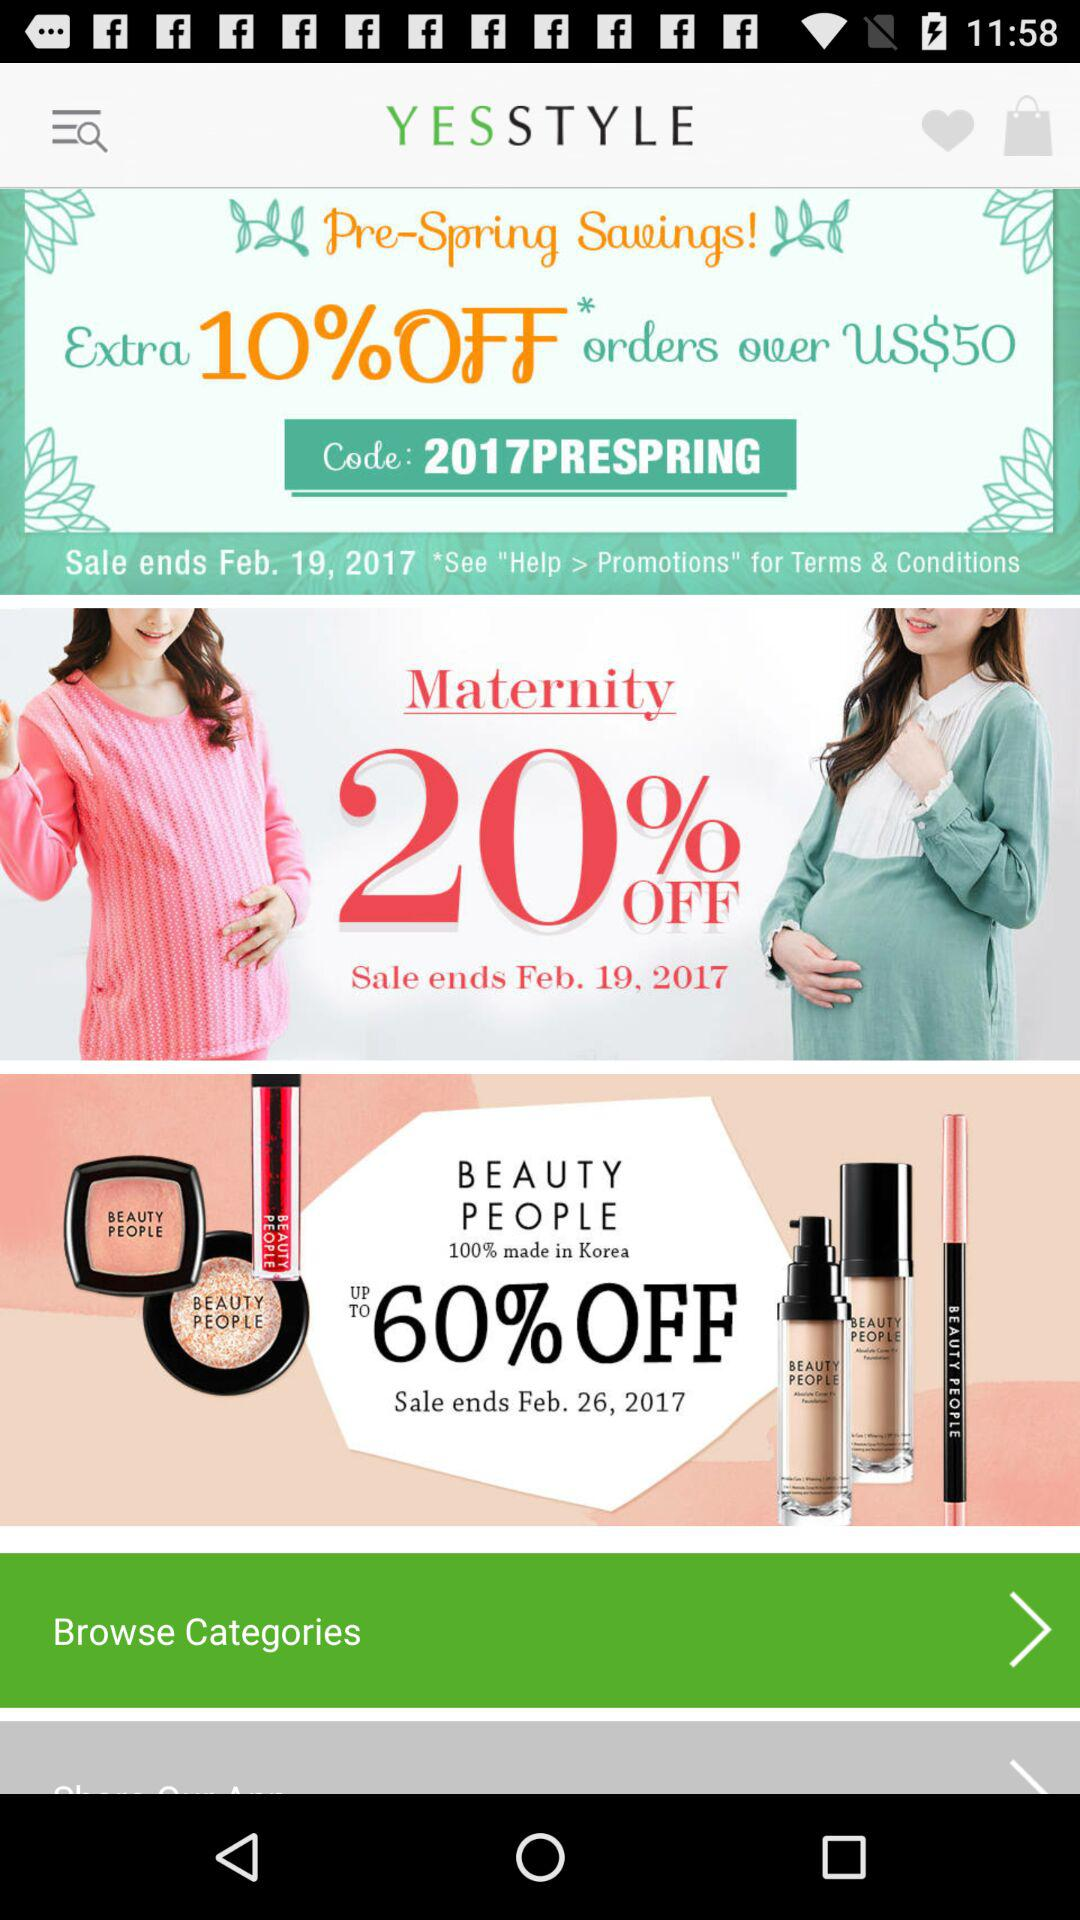What is the discount on beauty products? There is a discount of up to 60% on beauty products. 